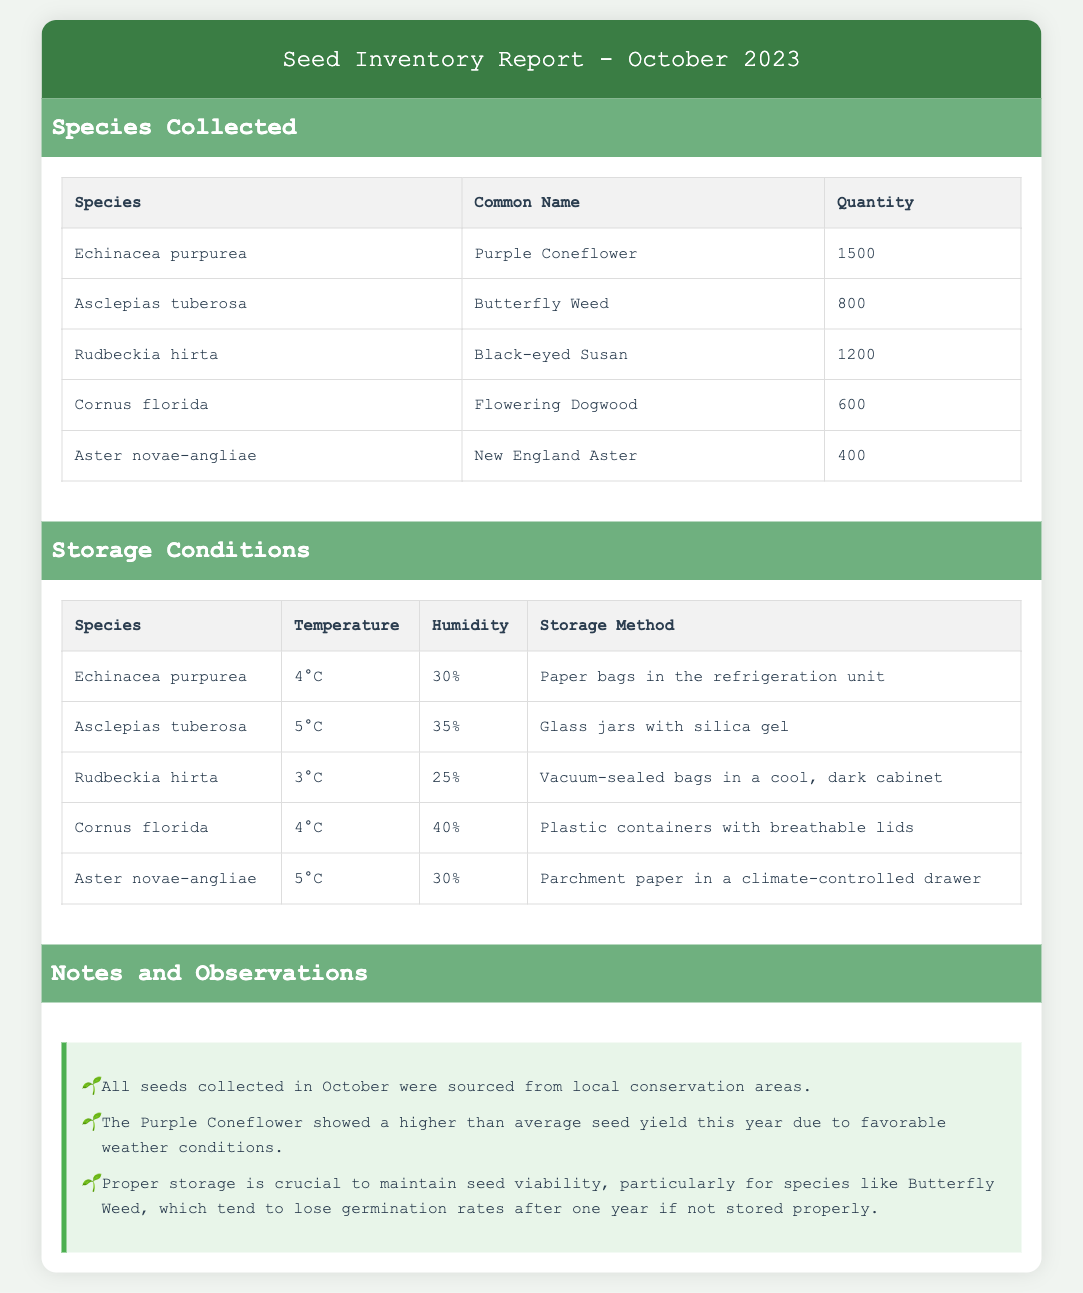What species had the highest quantity collected? The species with the highest quantity is found in the Species Collected table, which is Echinacea purpurea with 1500 seeds.
Answer: Echinacea purpurea How many Butterfly Weed seeds were collected? The quantity of Butterfly Weed seeds is detailed in the Species Collected table, which shows that 800 seeds were collected.
Answer: 800 What is the storage temperature for Black-eyed Susan? The storage temperature for Black-eyed Susan is noted in the Storage Conditions table, which lists it as 3°C.
Answer: 3°C What humidity level is maintained for Aster novae-angliae? The humidity level for Aster novae-angliae can be found in the Storage Conditions table, which states it is 30%.
Answer: 30% Which storage method is used for Echinacea purpurea? The storage method for Echinacea purpurea is specified in the Storage Conditions table as "Paper bags in the refrigeration unit".
Answer: Paper bags in the refrigeration unit How many different species were collected in October? The total number of different species is indicated in the Species Collected section, where five species are listed.
Answer: Five What is a key observation mentioned in the notes regarding the Purple Coneflower? The notes state that the Purple Coneflower showed a higher than average seed yield due to favorable weather conditions.
Answer: Higher than average seed yield What kind of containers are used for storing Cornus florida? The type of containers used for storing Cornus florida is stated in the Storage Conditions table as "Plastic containers with breathable lids".
Answer: Plastic containers with breathable lids What is the primary source for the seeds collected in October? The notes mention that all seeds were sourced from local conservation areas, providing context for their collection.
Answer: Local conservation areas 